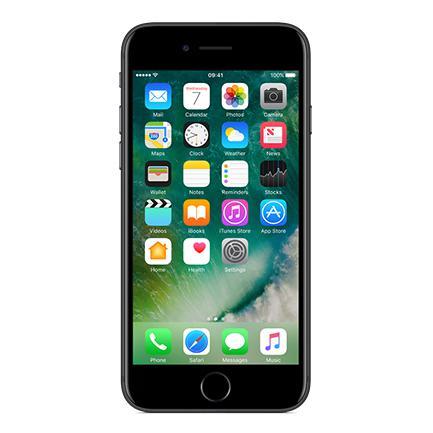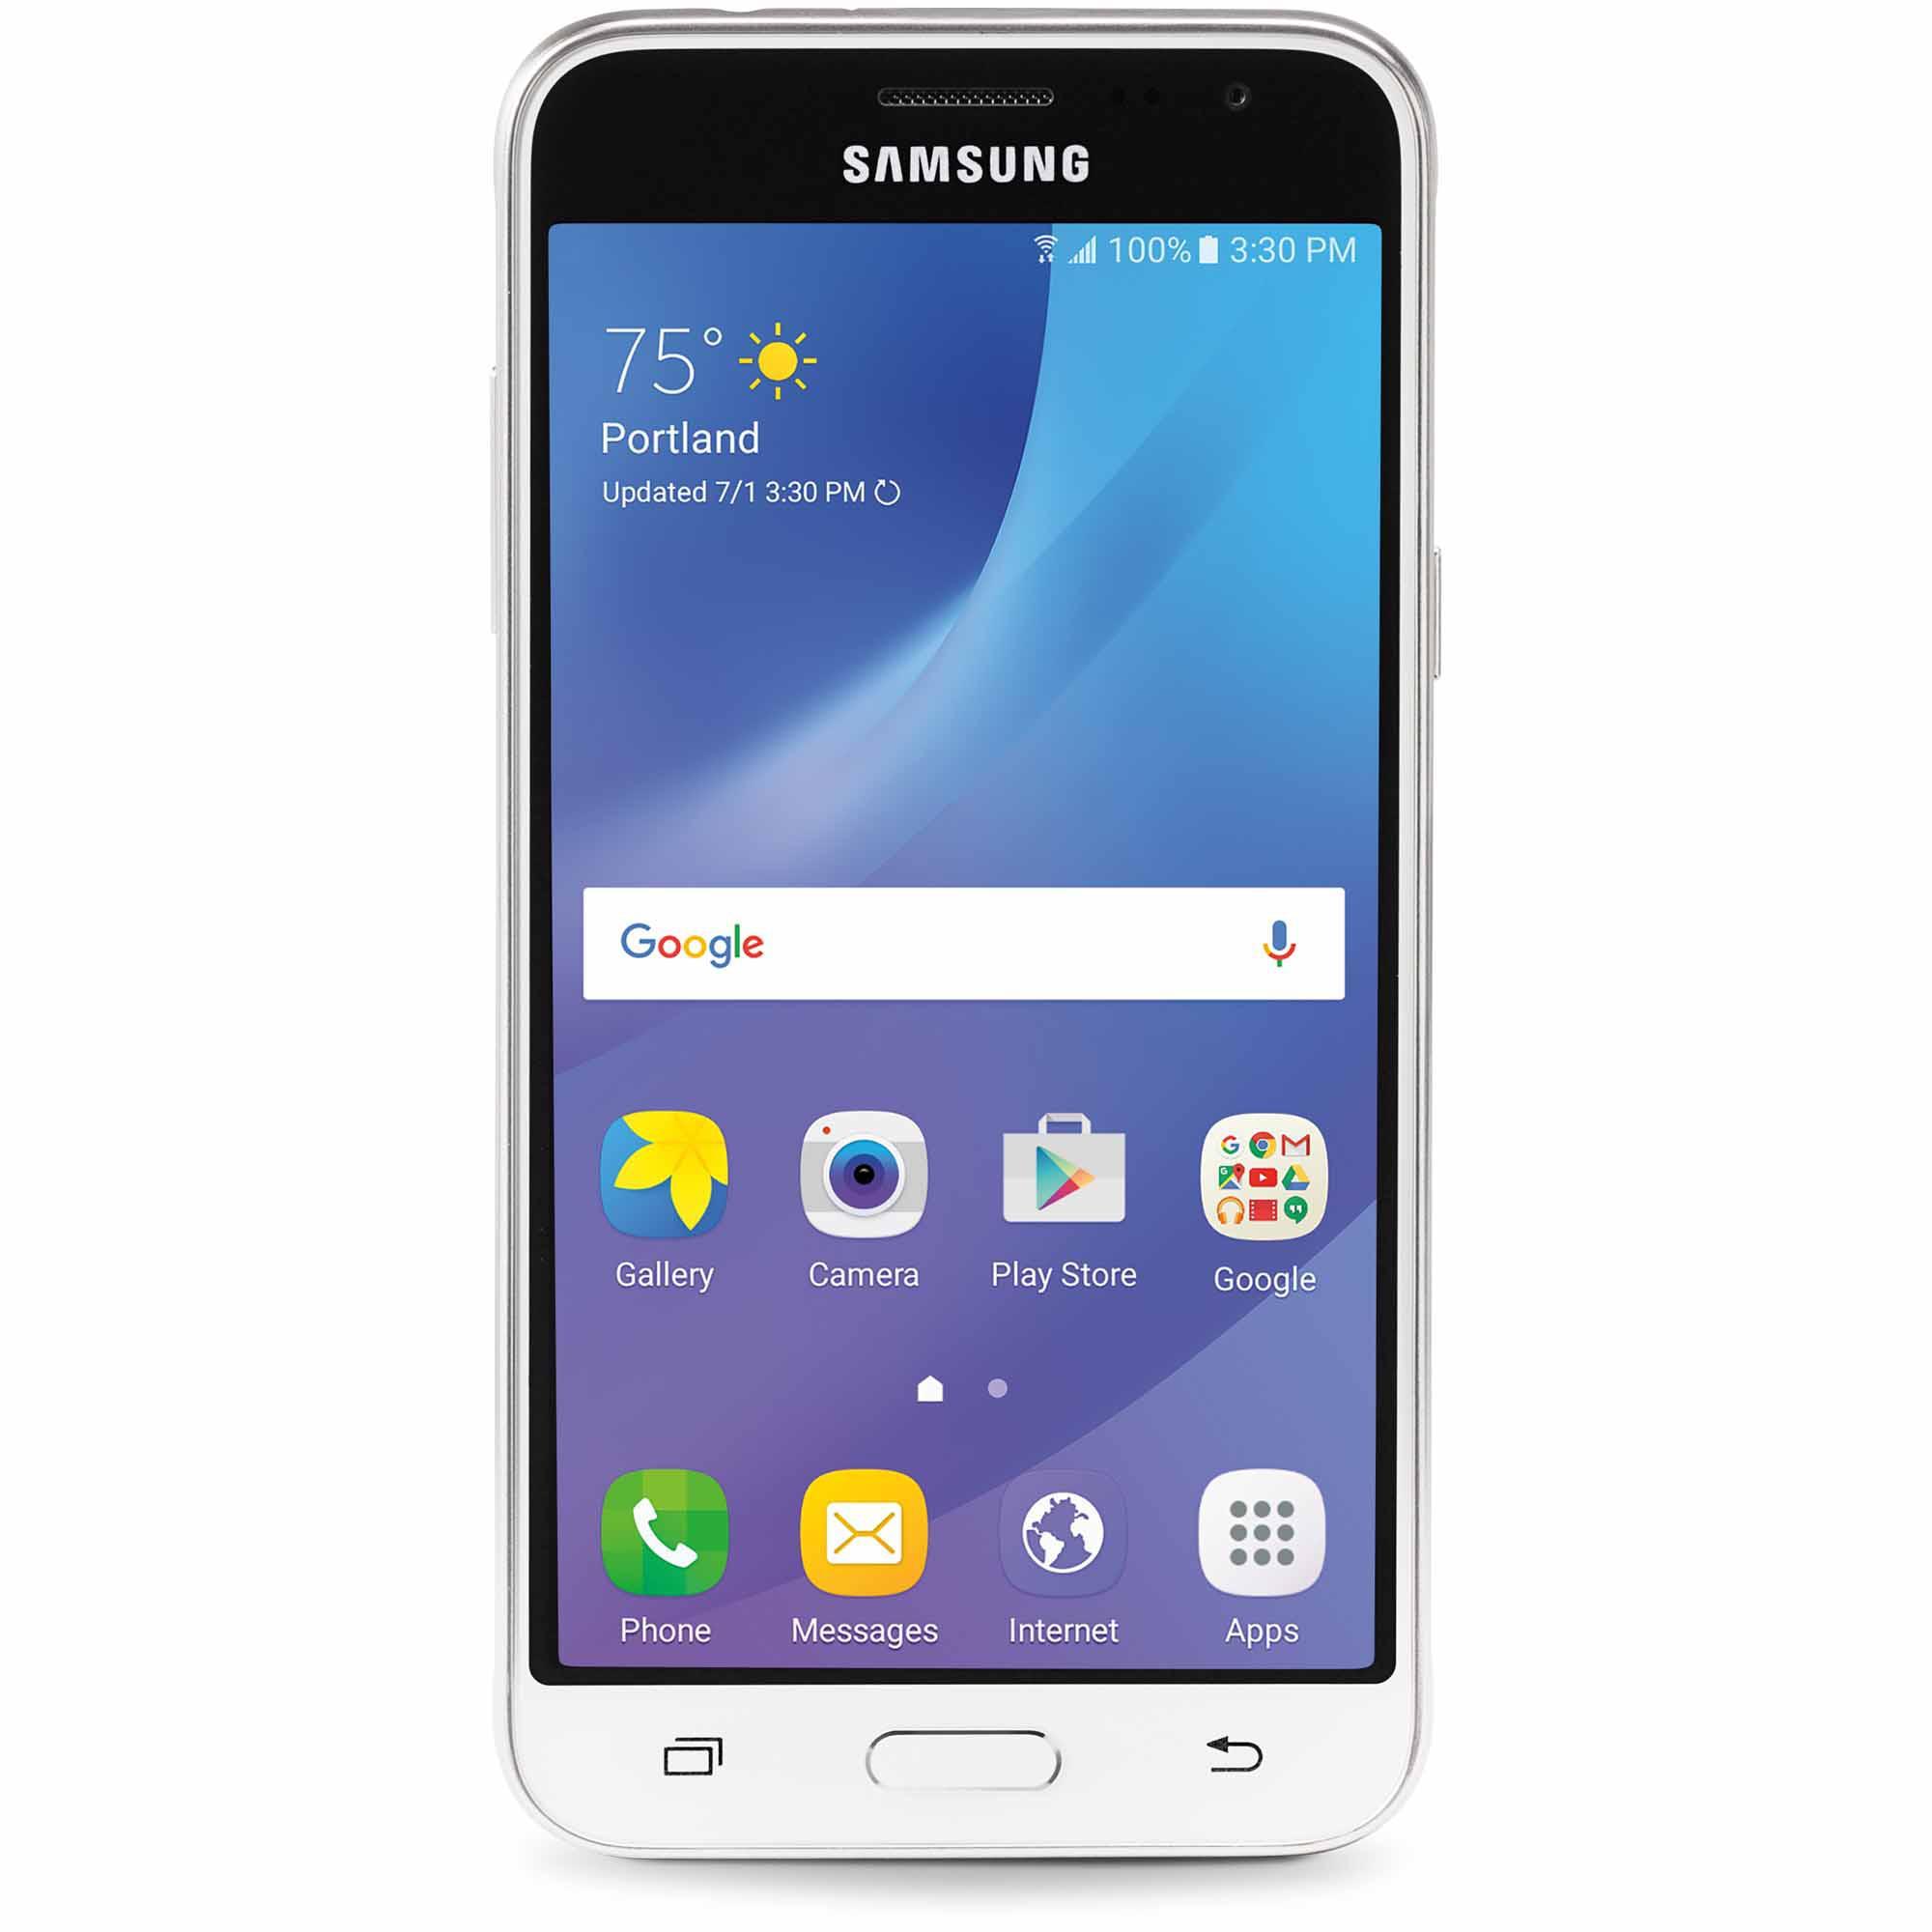The first image is the image on the left, the second image is the image on the right. For the images displayed, is the sentence "Each image shows a rectangular device with flat ends and sides, rounded corners, and 'lit' screen displayed head-on, and at least one of the devices is black." factually correct? Answer yes or no. Yes. 